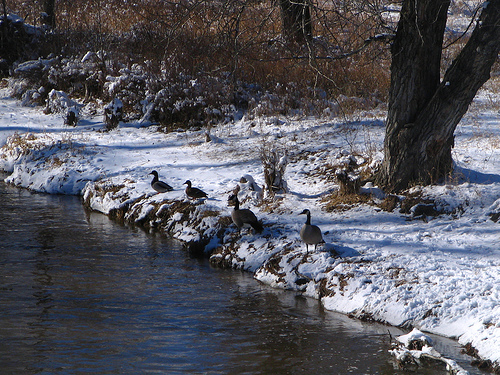<image>
Can you confirm if the tree is in the water? No. The tree is not contained within the water. These objects have a different spatial relationship. 